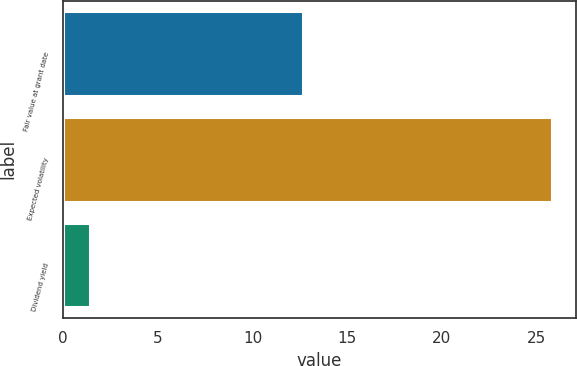Convert chart to OTSL. <chart><loc_0><loc_0><loc_500><loc_500><bar_chart><fcel>Fair value at grant date<fcel>Expected volatility<fcel>Dividend yield<nl><fcel>12.64<fcel>25.8<fcel>1.4<nl></chart> 